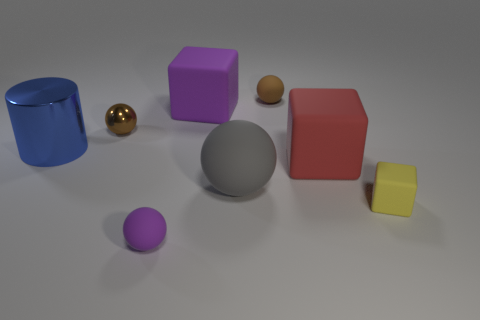Subtract all small yellow blocks. How many blocks are left? 2 Subtract all brown blocks. How many brown balls are left? 2 Subtract 3 spheres. How many spheres are left? 1 Add 2 small metal blocks. How many objects exist? 10 Subtract all purple blocks. How many blocks are left? 2 Subtract all cylinders. How many objects are left? 7 Subtract all small balls. Subtract all tiny blue metal cubes. How many objects are left? 5 Add 3 big objects. How many big objects are left? 7 Add 5 small yellow rubber objects. How many small yellow rubber objects exist? 6 Subtract 0 gray blocks. How many objects are left? 8 